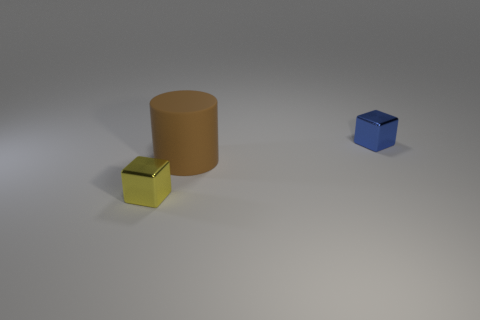Is there anything else that has the same size as the brown thing?
Give a very brief answer. No. What material is the other cube that is the same size as the yellow metallic block?
Provide a succinct answer. Metal. Are there any blue shiny things of the same size as the yellow thing?
Keep it short and to the point. Yes. Is the number of brown cylinders that are in front of the tiny yellow block the same as the number of large cylinders that are to the left of the tiny blue metallic block?
Your response must be concise. No. Is the number of big purple shiny things greater than the number of brown objects?
Offer a terse response. No. How many metal objects are brown objects or large cyan cylinders?
Make the answer very short. 0. There is a tiny thing that is right of the metallic object left of the tiny blue thing right of the large matte object; what is its material?
Your answer should be very brief. Metal. There is a metal object that is behind the yellow block that is left of the large rubber cylinder; what color is it?
Provide a short and direct response. Blue. How many tiny things are yellow metal blocks or blue shiny cubes?
Your answer should be compact. 2. How many yellow things have the same material as the tiny blue cube?
Provide a succinct answer. 1. 